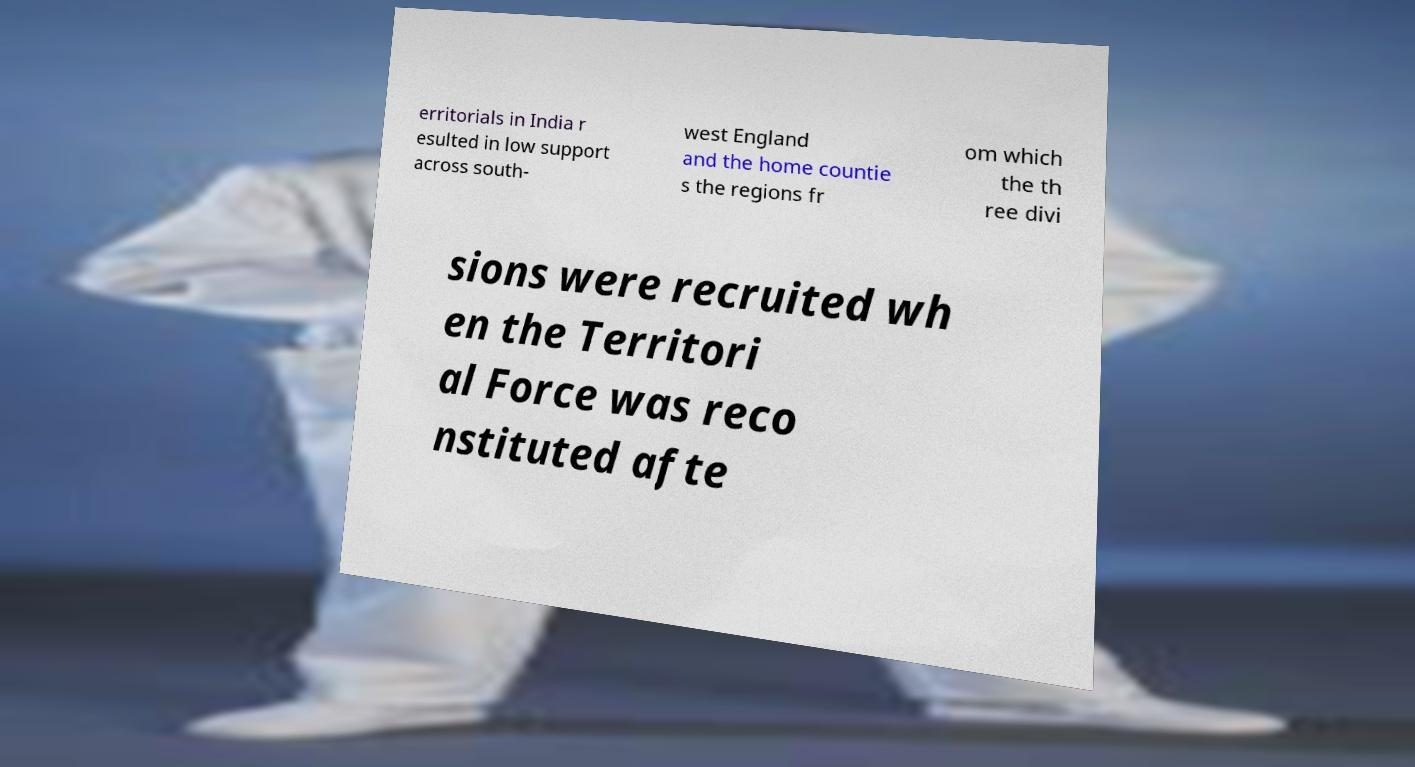I need the written content from this picture converted into text. Can you do that? erritorials in India r esulted in low support across south- west England and the home countie s the regions fr om which the th ree divi sions were recruited wh en the Territori al Force was reco nstituted afte 